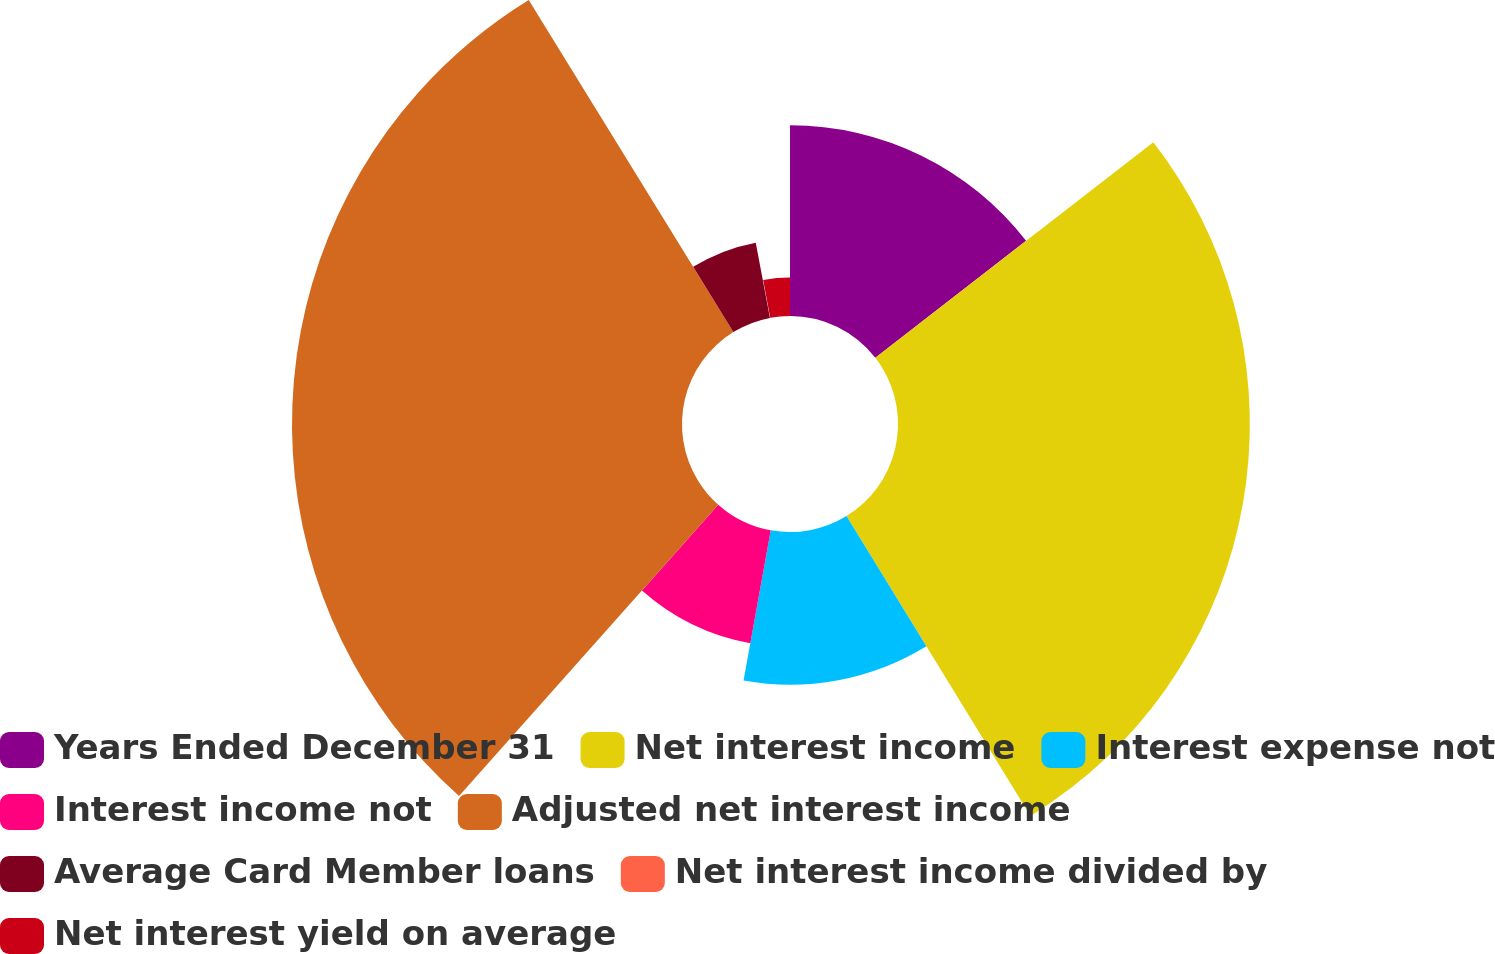<chart> <loc_0><loc_0><loc_500><loc_500><pie_chart><fcel>Years Ended December 31<fcel>Net interest income<fcel>Interest expense not<fcel>Interest income not<fcel>Adjusted net interest income<fcel>Average Card Member loans<fcel>Net interest income divided by<fcel>Net interest yield on average<nl><fcel>14.5%<fcel>26.74%<fcel>11.61%<fcel>8.72%<fcel>29.64%<fcel>5.82%<fcel>0.04%<fcel>2.93%<nl></chart> 